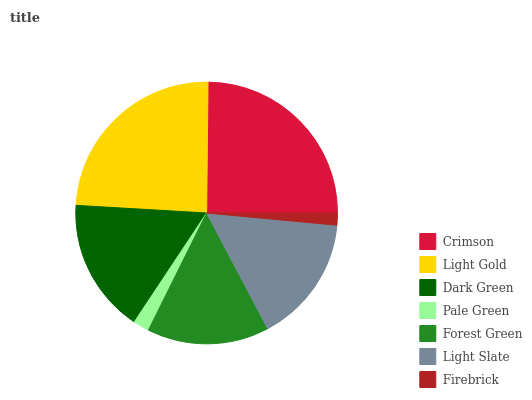Is Firebrick the minimum?
Answer yes or no. Yes. Is Crimson the maximum?
Answer yes or no. Yes. Is Light Gold the minimum?
Answer yes or no. No. Is Light Gold the maximum?
Answer yes or no. No. Is Crimson greater than Light Gold?
Answer yes or no. Yes. Is Light Gold less than Crimson?
Answer yes or no. Yes. Is Light Gold greater than Crimson?
Answer yes or no. No. Is Crimson less than Light Gold?
Answer yes or no. No. Is Light Slate the high median?
Answer yes or no. Yes. Is Light Slate the low median?
Answer yes or no. Yes. Is Dark Green the high median?
Answer yes or no. No. Is Firebrick the low median?
Answer yes or no. No. 